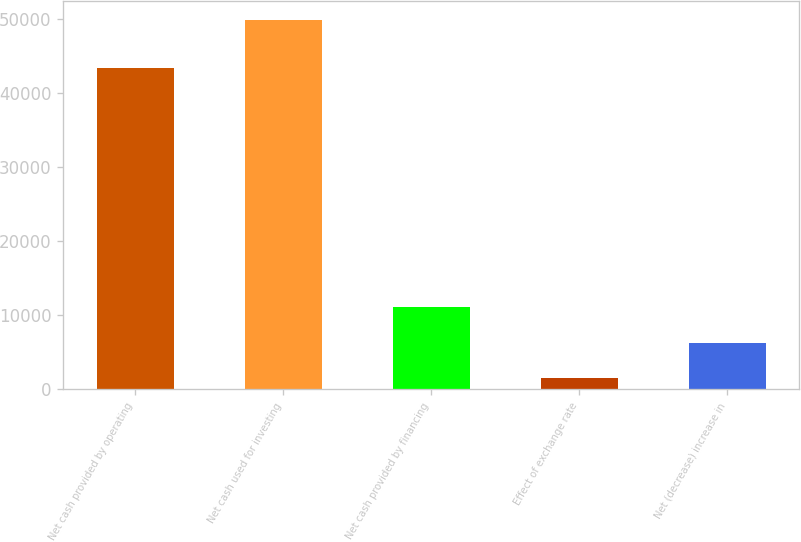Convert chart to OTSL. <chart><loc_0><loc_0><loc_500><loc_500><bar_chart><fcel>Net cash provided by operating<fcel>Net cash used for investing<fcel>Net cash provided by financing<fcel>Effect of exchange rate<fcel>Net (decrease) increase in<nl><fcel>43290<fcel>49863<fcel>11144.6<fcel>1465<fcel>6304.8<nl></chart> 